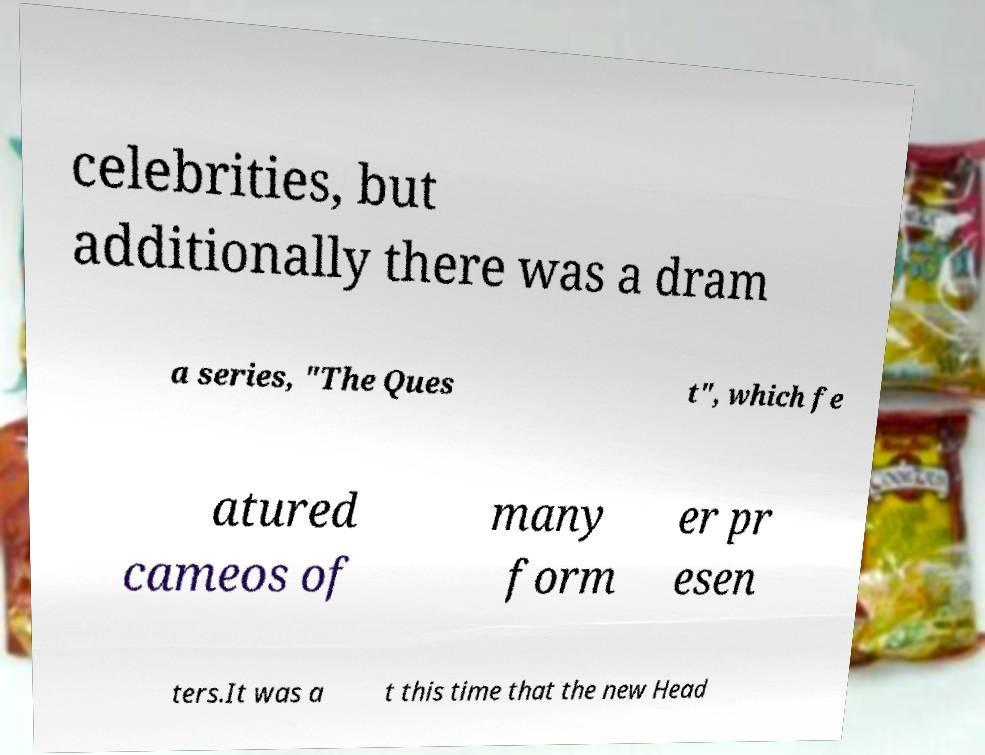Please read and relay the text visible in this image. What does it say? celebrities, but additionally there was a dram a series, "The Ques t", which fe atured cameos of many form er pr esen ters.It was a t this time that the new Head 